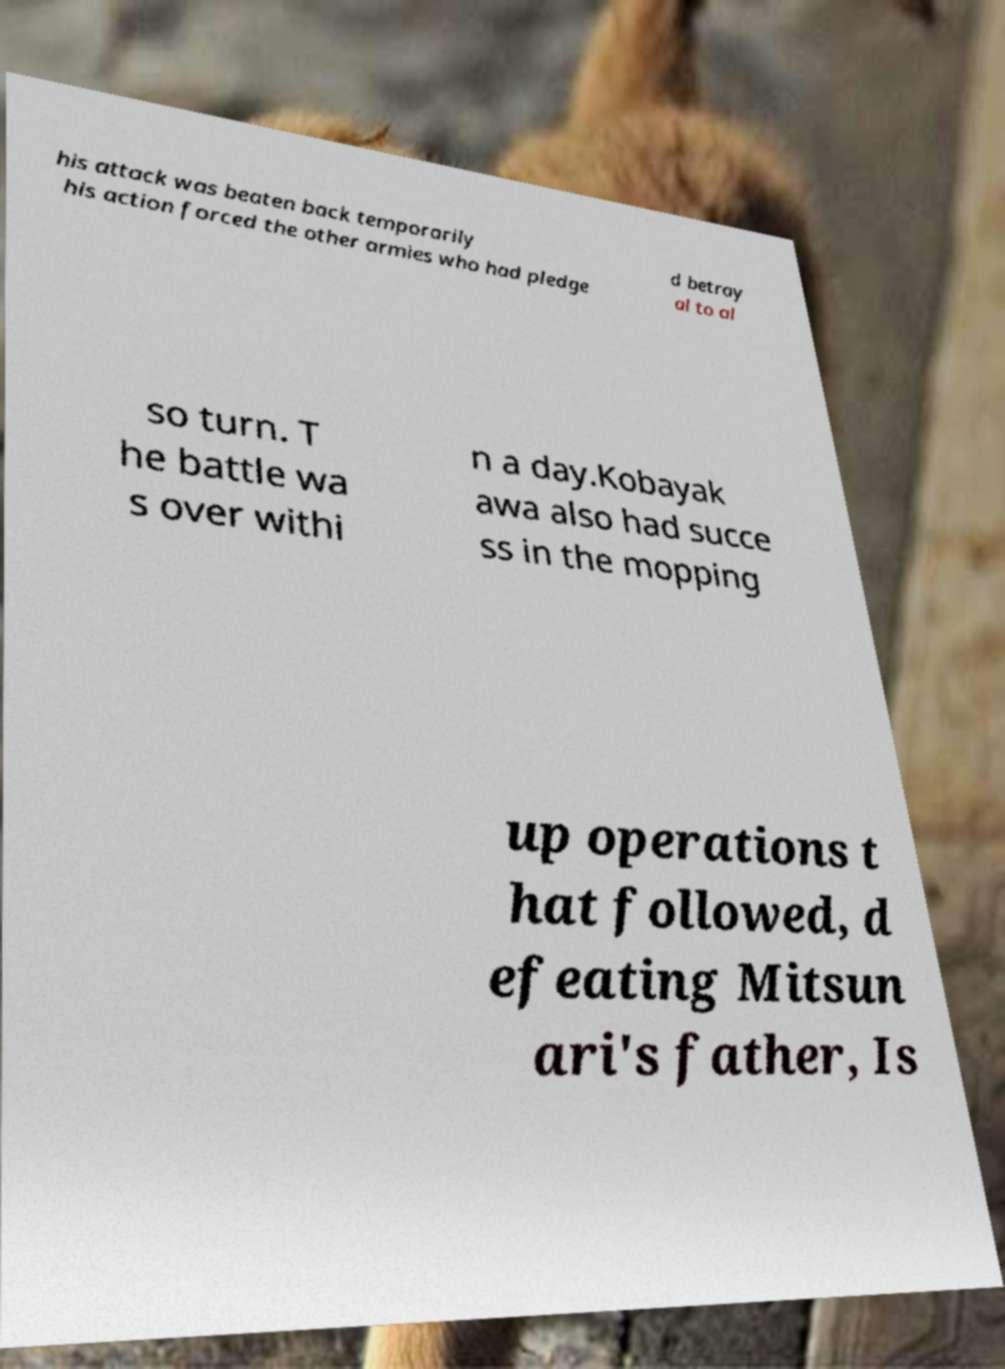What messages or text are displayed in this image? I need them in a readable, typed format. his attack was beaten back temporarily his action forced the other armies who had pledge d betray al to al so turn. T he battle wa s over withi n a day.Kobayak awa also had succe ss in the mopping up operations t hat followed, d efeating Mitsun ari's father, Is 